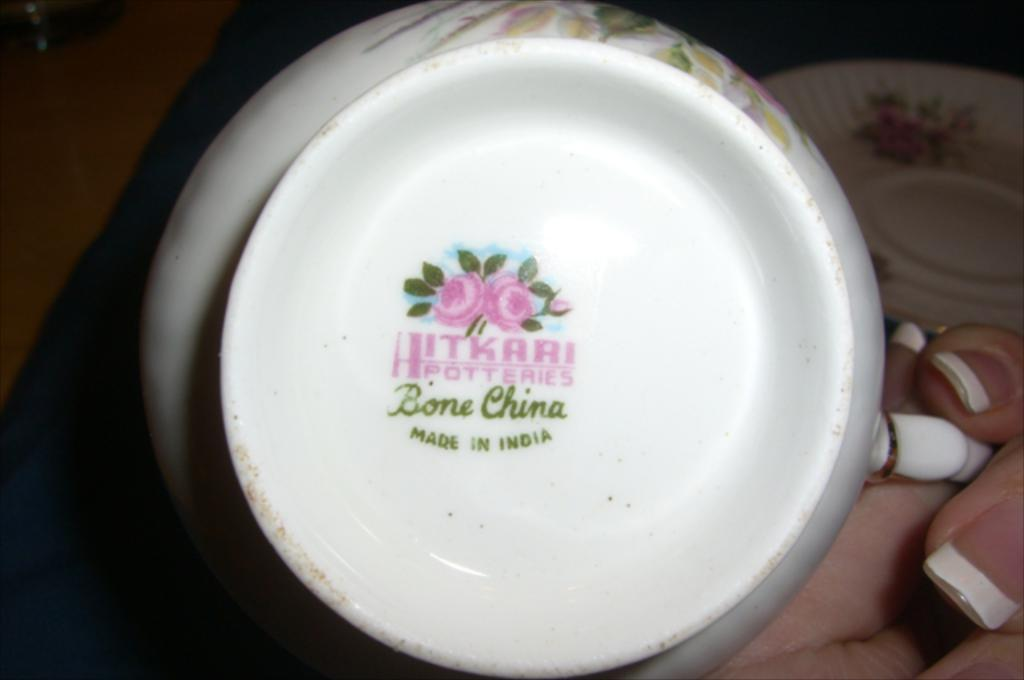What is one object visible in the image? There is a cup in the image. How is the cup positioned in the image? The cup is in the reverse direction. What other object can be seen in the image? There is a plate in the image. Where is the plate located in the image? The plate is on the right side top. How many dogs are present in the image? There are no dogs present in the image. What type of crowd can be seen gathering around the plate in the image? There is no crowd present in the image; it only shows a cup and a plate. 